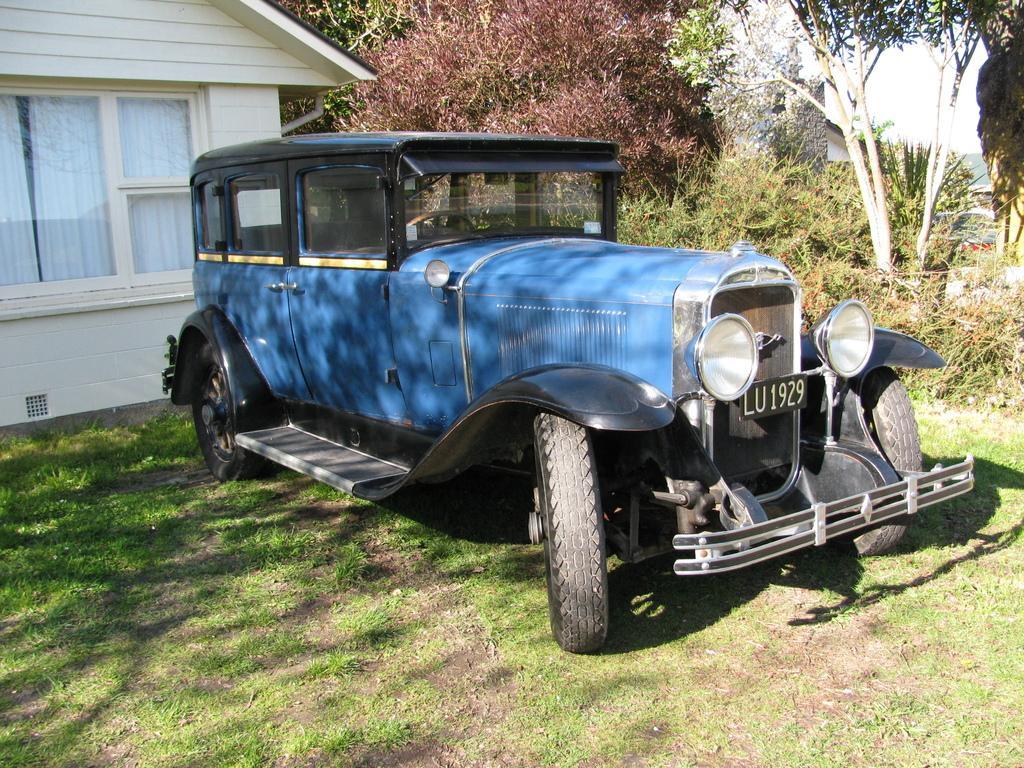In one or two sentences, can you explain what this image depicts? There one vehicle present on a grassy land as we can see in the middle of this image. We can see a house on the left side of this image, and there are some trees in the background. 